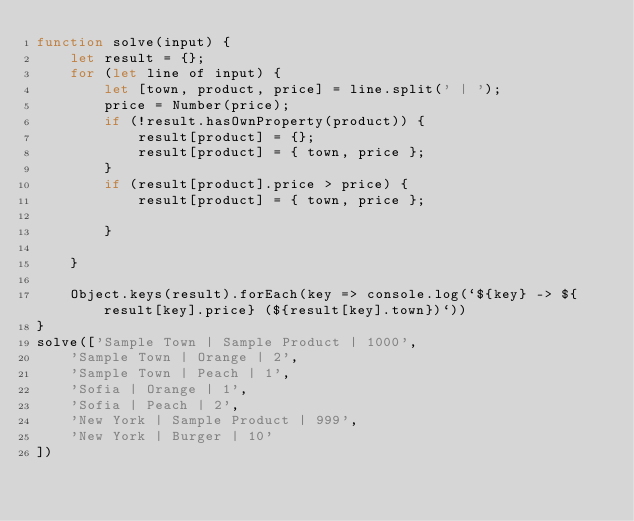<code> <loc_0><loc_0><loc_500><loc_500><_JavaScript_>function solve(input) {
    let result = {};
    for (let line of input) {
        let [town, product, price] = line.split(' | ');
        price = Number(price);
        if (!result.hasOwnProperty(product)) {
            result[product] = {};
            result[product] = { town, price };
        }
        if (result[product].price > price) {
            result[product] = { town, price };

        }

    }

    Object.keys(result).forEach(key => console.log(`${key} -> ${result[key].price} (${result[key].town})`))
}
solve(['Sample Town | Sample Product | 1000',
    'Sample Town | Orange | 2',
    'Sample Town | Peach | 1',
    'Sofia | Orange | 1',
    'Sofia | Peach | 2',
    'New York | Sample Product | 999',
    'New York | Burger | 10'
])</code> 